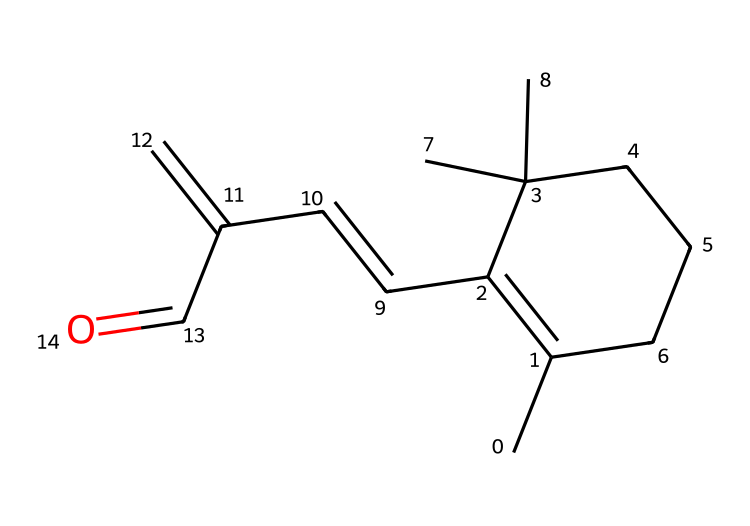How many carbon atoms are present in the structure? By analyzing the SMILES representation, we can count the number of carbon symbols "C." There are 16 carbon atoms in total.
Answer: 16 What functional group does this chemical contain? The presence of the carbonyl group (C=O) at the end of the structure indicates that this chemical is an aldehyde.
Answer: aldehyde What is the degree of substitution of the carbon chain with methyl groups? By examining the structure, we see that there are 3 methyl groups (indicated by the "C" symbols branching off the main chain).
Answer: 3 What is the molecular formula of this aldehyde? To find the molecular formula, we summarize the number of carbon (C), hydrogen (H), and oxygen (O) atoms from the structure: C16H26O.
Answer: C16H26O Which element gives this compound its oxidation state of +1? The oxygen atom in the aldehyde functional group signifies an oxidation state of +1, as it is bonded to hydrogen and carbon.
Answer: oxygen What type of reaction might this aldehyde undergo in skincare applications? Aldehydes can undergo oxidation to form acids or condensation reactions in skincare formulations, often enhancing their efficacy in anti-aging.
Answer: oxidation 